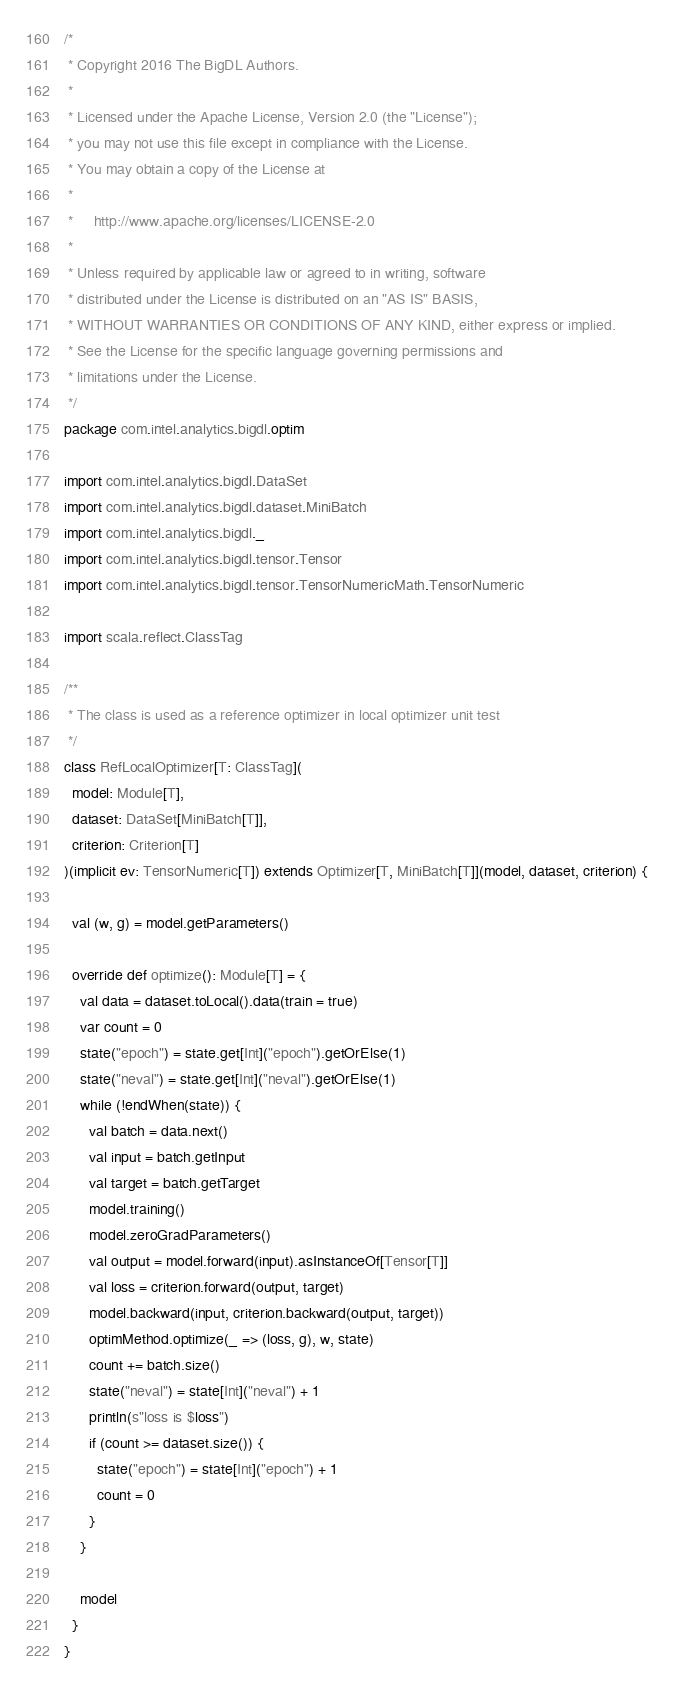<code> <loc_0><loc_0><loc_500><loc_500><_Scala_>/*
 * Copyright 2016 The BigDL Authors.
 *
 * Licensed under the Apache License, Version 2.0 (the "License");
 * you may not use this file except in compliance with the License.
 * You may obtain a copy of the License at
 *
 *     http://www.apache.org/licenses/LICENSE-2.0
 *
 * Unless required by applicable law or agreed to in writing, software
 * distributed under the License is distributed on an "AS IS" BASIS,
 * WITHOUT WARRANTIES OR CONDITIONS OF ANY KIND, either express or implied.
 * See the License for the specific language governing permissions and
 * limitations under the License.
 */
package com.intel.analytics.bigdl.optim

import com.intel.analytics.bigdl.DataSet
import com.intel.analytics.bigdl.dataset.MiniBatch
import com.intel.analytics.bigdl._
import com.intel.analytics.bigdl.tensor.Tensor
import com.intel.analytics.bigdl.tensor.TensorNumericMath.TensorNumeric

import scala.reflect.ClassTag

/**
 * The class is used as a reference optimizer in local optimizer unit test
 */
class RefLocalOptimizer[T: ClassTag](
  model: Module[T],
  dataset: DataSet[MiniBatch[T]],
  criterion: Criterion[T]
)(implicit ev: TensorNumeric[T]) extends Optimizer[T, MiniBatch[T]](model, dataset, criterion) {

  val (w, g) = model.getParameters()

  override def optimize(): Module[T] = {
    val data = dataset.toLocal().data(train = true)
    var count = 0
    state("epoch") = state.get[Int]("epoch").getOrElse(1)
    state("neval") = state.get[Int]("neval").getOrElse(1)
    while (!endWhen(state)) {
      val batch = data.next()
      val input = batch.getInput
      val target = batch.getTarget
      model.training()
      model.zeroGradParameters()
      val output = model.forward(input).asInstanceOf[Tensor[T]]
      val loss = criterion.forward(output, target)
      model.backward(input, criterion.backward(output, target))
      optimMethod.optimize(_ => (loss, g), w, state)
      count += batch.size()
      state("neval") = state[Int]("neval") + 1
      println(s"loss is $loss")
      if (count >= dataset.size()) {
        state("epoch") = state[Int]("epoch") + 1
        count = 0
      }
    }

    model
  }
}
</code> 